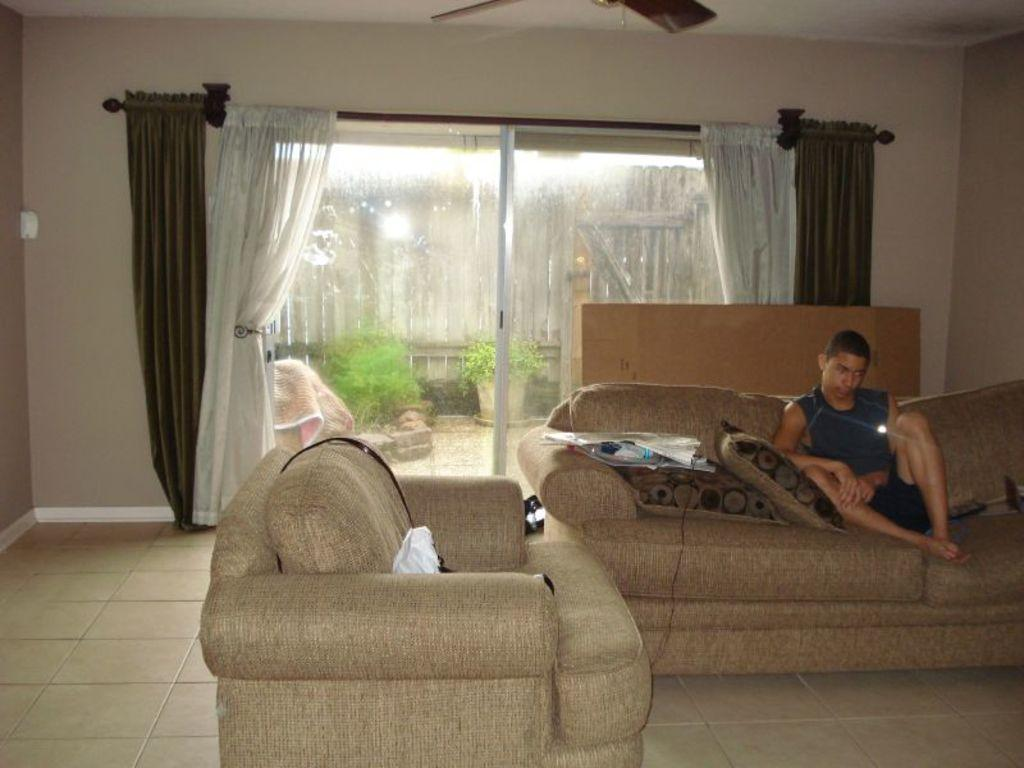What type of room is depicted in the image? The image depicts a living room. What furniture is present in the living room? There is a couch in the living room. What is placed on the couch? Pillows and covers are present on the couch. Who is in the living room? A man is sitting on the couch. What additional items can be seen in the living room? There is a cardboard box, curtains, a window, plants, a blanket, a fan, and a wooden fence visible in the living room. What type of fruit is being sold in the living room? There is no fruit being sold in the living room; the image does not depict any fruit or sales activity. 